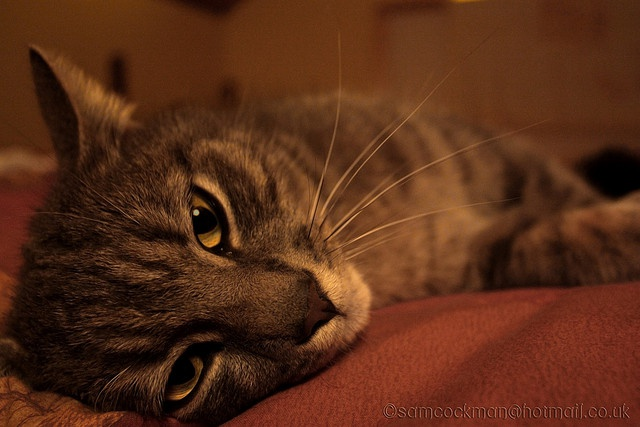Describe the objects in this image and their specific colors. I can see cat in maroon, black, and brown tones and bed in maroon, brown, and black tones in this image. 